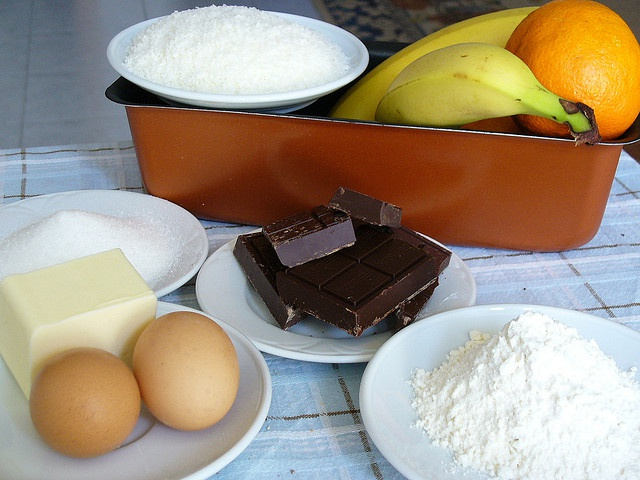Describe the objects in this image and their specific colors. I can see dining table in blue, lightgray, darkgray, lightblue, and black tones, bowl in blue, white, lightblue, darkgray, and black tones, banana in blue, olive, and khaki tones, and orange in blue, orange, brown, and gold tones in this image. 